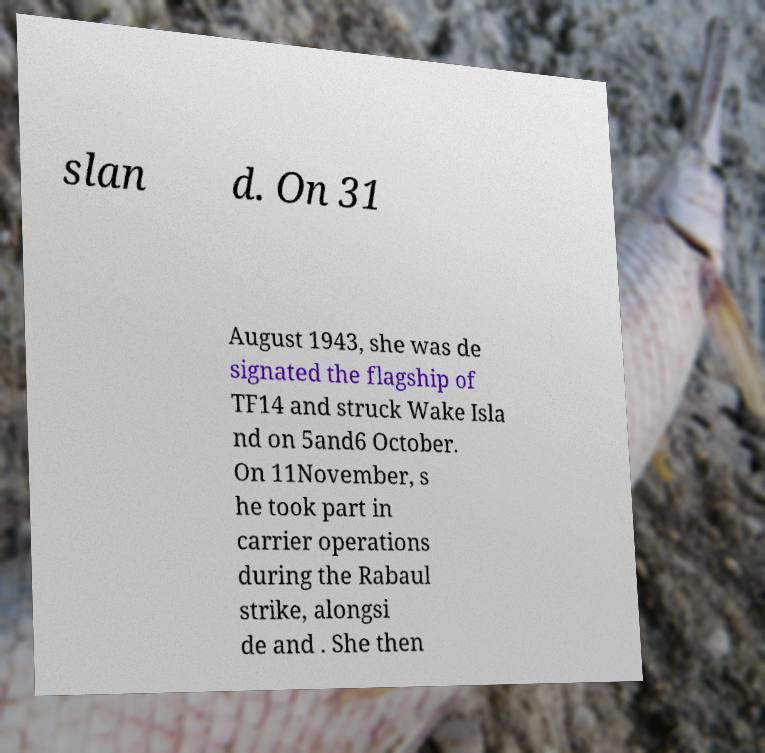For documentation purposes, I need the text within this image transcribed. Could you provide that? slan d. On 31 August 1943, she was de signated the flagship of TF14 and struck Wake Isla nd on 5and6 October. On 11November, s he took part in carrier operations during the Rabaul strike, alongsi de and . She then 